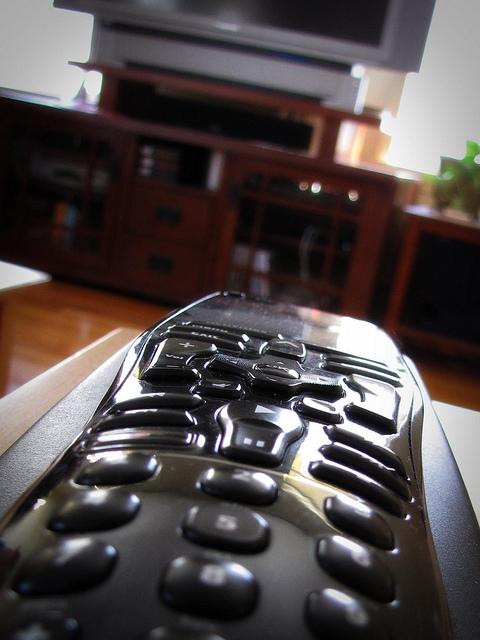What is black in this picture?
Answer briefly. Remote. Do you see a TV?
Give a very brief answer. Yes. Is the 'record' button on the remote visible?
Keep it brief. No. 